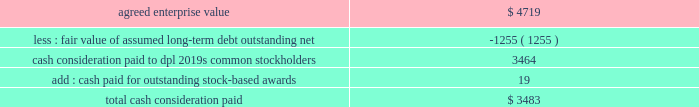The aes corporation notes to consolidated financial statements 2014 ( continued ) december 31 , 2011 , 2010 , and 2009 company for an aggregate proceeds of approximately $ 234 million .
The company recognized a gain on disposal of $ 6 million , net of tax , during the year ended december 31 , 2010 .
Ras laffan was previously reported in the asia generation segment .
23 .
Acquisitions and dispositions acquisitions dpl 2014on november 28 , 2011 , aes completed its acquisition of 100% ( 100 % ) of the common stock of dpl for approximately $ 3.5 billion , pursuant to the terms and conditions of a definitive agreement ( the 201cmerger agreement 201d ) dated april 19 , 2011 .
Dpl serves over 500000 customers , primarily west central ohio , through its operating subsidiaries dp&l and dpl energy resources ( 201cdpler 201d ) .
Additionally , dpl operates over 3800 mw of power generation facilities and provides competitive retail energy services to residential , commercial , industrial and governmental customers .
The acquisition strengthens the company 2019s u.s .
Utility operations by expanding in the midwest and pjm , a regional transmission organization serving several eastern states as part of the eastern interconnection .
The company expects to benefit from the regional scale provided by indianapolis power & light company , its nearby integrated utility business in indiana .
Aes funded the aggregate purchase consideration through a combination of the following : 2022 the proceeds from a $ 1.05 billion term loan obtained in may 2011 ; 2022 the proceeds from a private offering of $ 1.0 billion notes in june 2011 ; 2022 temporary borrowings of $ 251 million under its revolving credit facility ; and 2022 the proceeds from private offerings of $ 450 million aggregate principal amount of 6.50% ( 6.50 % ) senior notes due 2016 and $ 800 million aggregate principal amount of 7.25% ( 7.25 % ) senior notes due 2021 ( collectively , the 201cnotes 201d ) in october 2011 by dolphin subsidiary ii , inc .
( 201cdolphin ii 201d ) , a wholly-owned special purpose indirect subsidiary of aes , which was merged into dpl upon the completion of acquisition .
The fair value of the consideration paid for dpl was as follows ( in millions ) : .

How much of the dpl purchase price was funded by existing credit facilities as opposed to new borrowing? 
Computations: (251 / (3.5 * 1000))
Answer: 0.07171. 